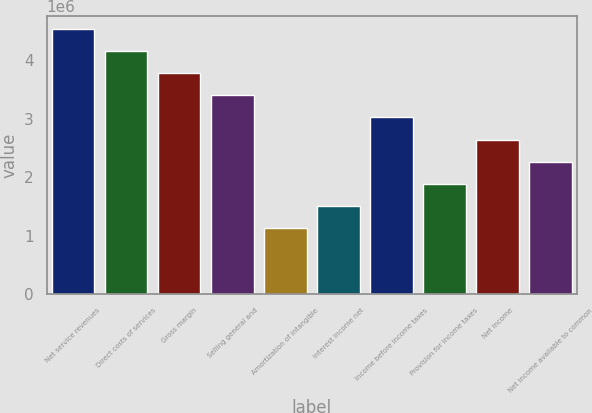Convert chart. <chart><loc_0><loc_0><loc_500><loc_500><bar_chart><fcel>Net service revenues<fcel>Direct costs of services<fcel>Gross margin<fcel>Selling general and<fcel>Amortization of intangible<fcel>Interest income net<fcel>Income before income taxes<fcel>Provision for income taxes<fcel>Net income<fcel>Net income available to common<nl><fcel>4.53237e+06<fcel>4.15467e+06<fcel>3.77698e+06<fcel>3.39928e+06<fcel>1.13309e+06<fcel>1.51079e+06<fcel>3.02158e+06<fcel>1.88849e+06<fcel>2.64388e+06<fcel>2.26619e+06<nl></chart> 